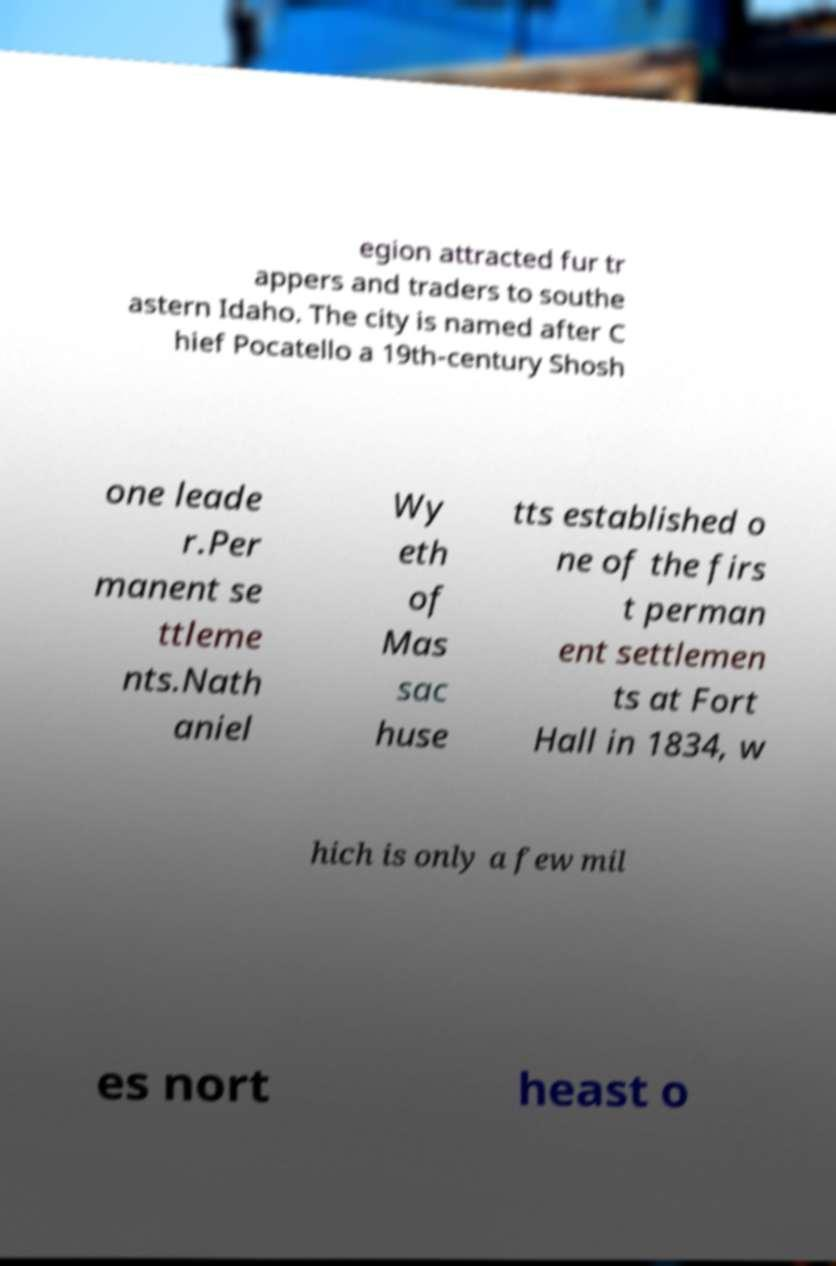I need the written content from this picture converted into text. Can you do that? egion attracted fur tr appers and traders to southe astern Idaho. The city is named after C hief Pocatello a 19th-century Shosh one leade r.Per manent se ttleme nts.Nath aniel Wy eth of Mas sac huse tts established o ne of the firs t perman ent settlemen ts at Fort Hall in 1834, w hich is only a few mil es nort heast o 